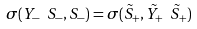Convert formula to latex. <formula><loc_0><loc_0><loc_500><loc_500>\sigma ( Y _ { - } \ S _ { - } , S _ { - } ) = \sigma ( \tilde { S } _ { + } , \tilde { Y } _ { + } \ \tilde { S } _ { + } )</formula> 